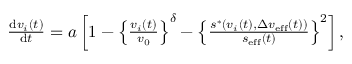Convert formula to latex. <formula><loc_0><loc_0><loc_500><loc_500>\begin{array} { r } { \frac { d v _ { i } ( t ) } { d t } = a \left [ 1 - \left \{ \frac { v _ { i } ( t ) } { v _ { 0 } } \right \} ^ { \delta } - \left \{ \frac { s ^ { \ast } \left ( v _ { i } ( t ) , \Delta v _ { e f f } ( t ) \right ) } { s _ { e f f } ( t ) } \right \} ^ { 2 } \right ] , } \end{array}</formula> 